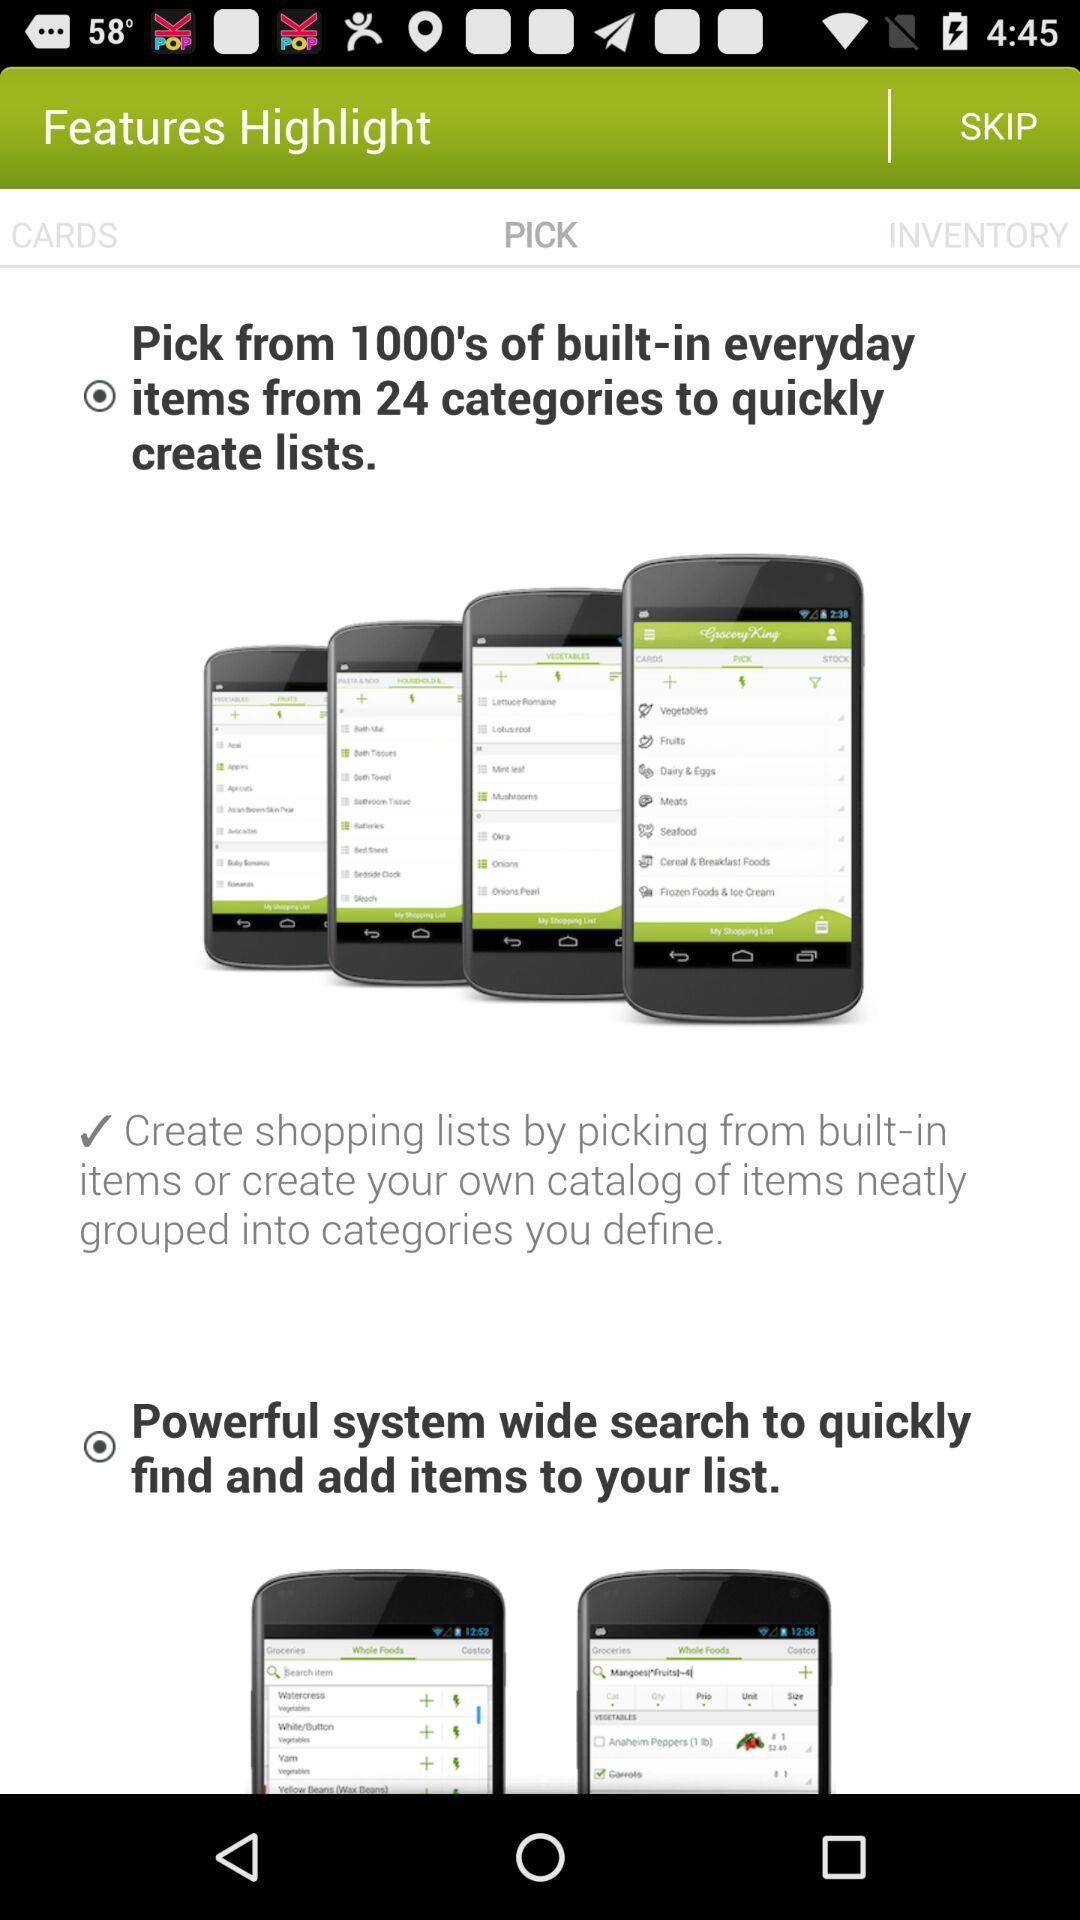Which tab is selected? The selected tab is "PICK". 